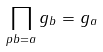Convert formula to latex. <formula><loc_0><loc_0><loc_500><loc_500>\prod _ { p b = a } g _ { b } = g _ { a }</formula> 